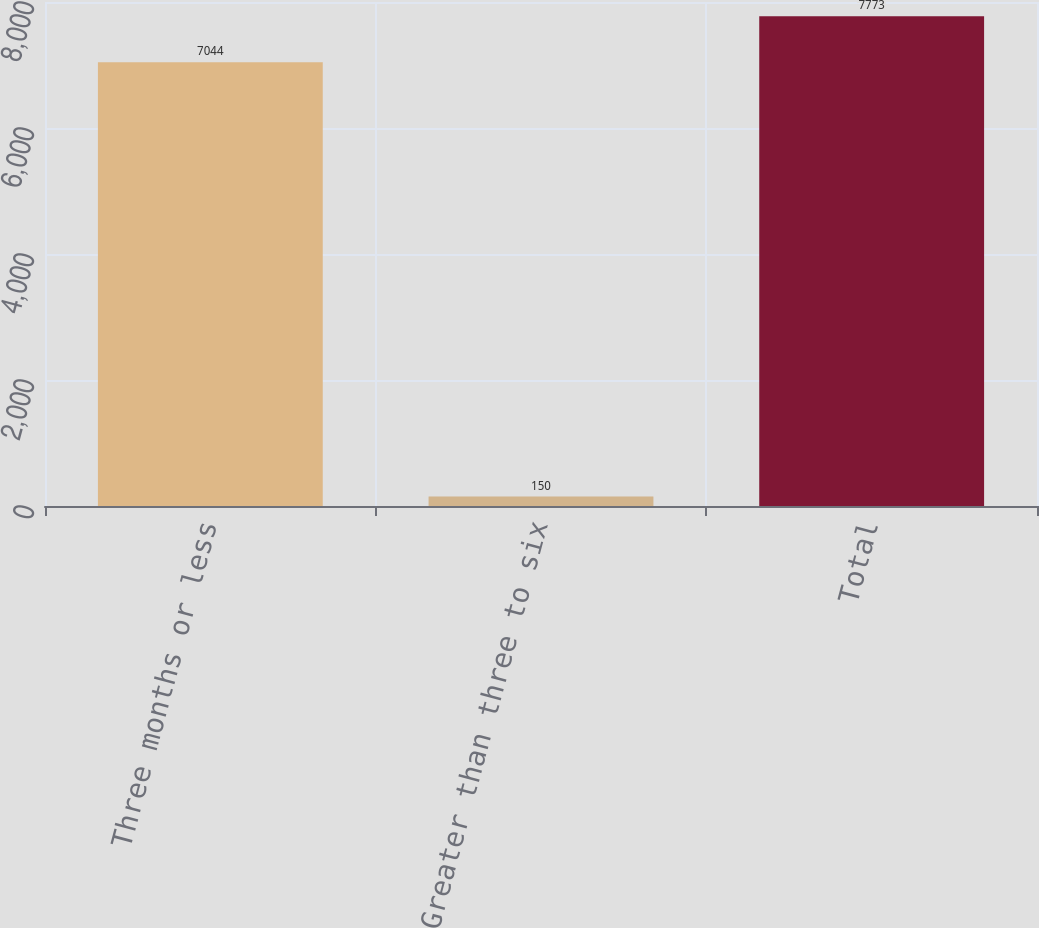Convert chart to OTSL. <chart><loc_0><loc_0><loc_500><loc_500><bar_chart><fcel>Three months or less<fcel>Greater than three to six<fcel>Total<nl><fcel>7044<fcel>150<fcel>7773<nl></chart> 